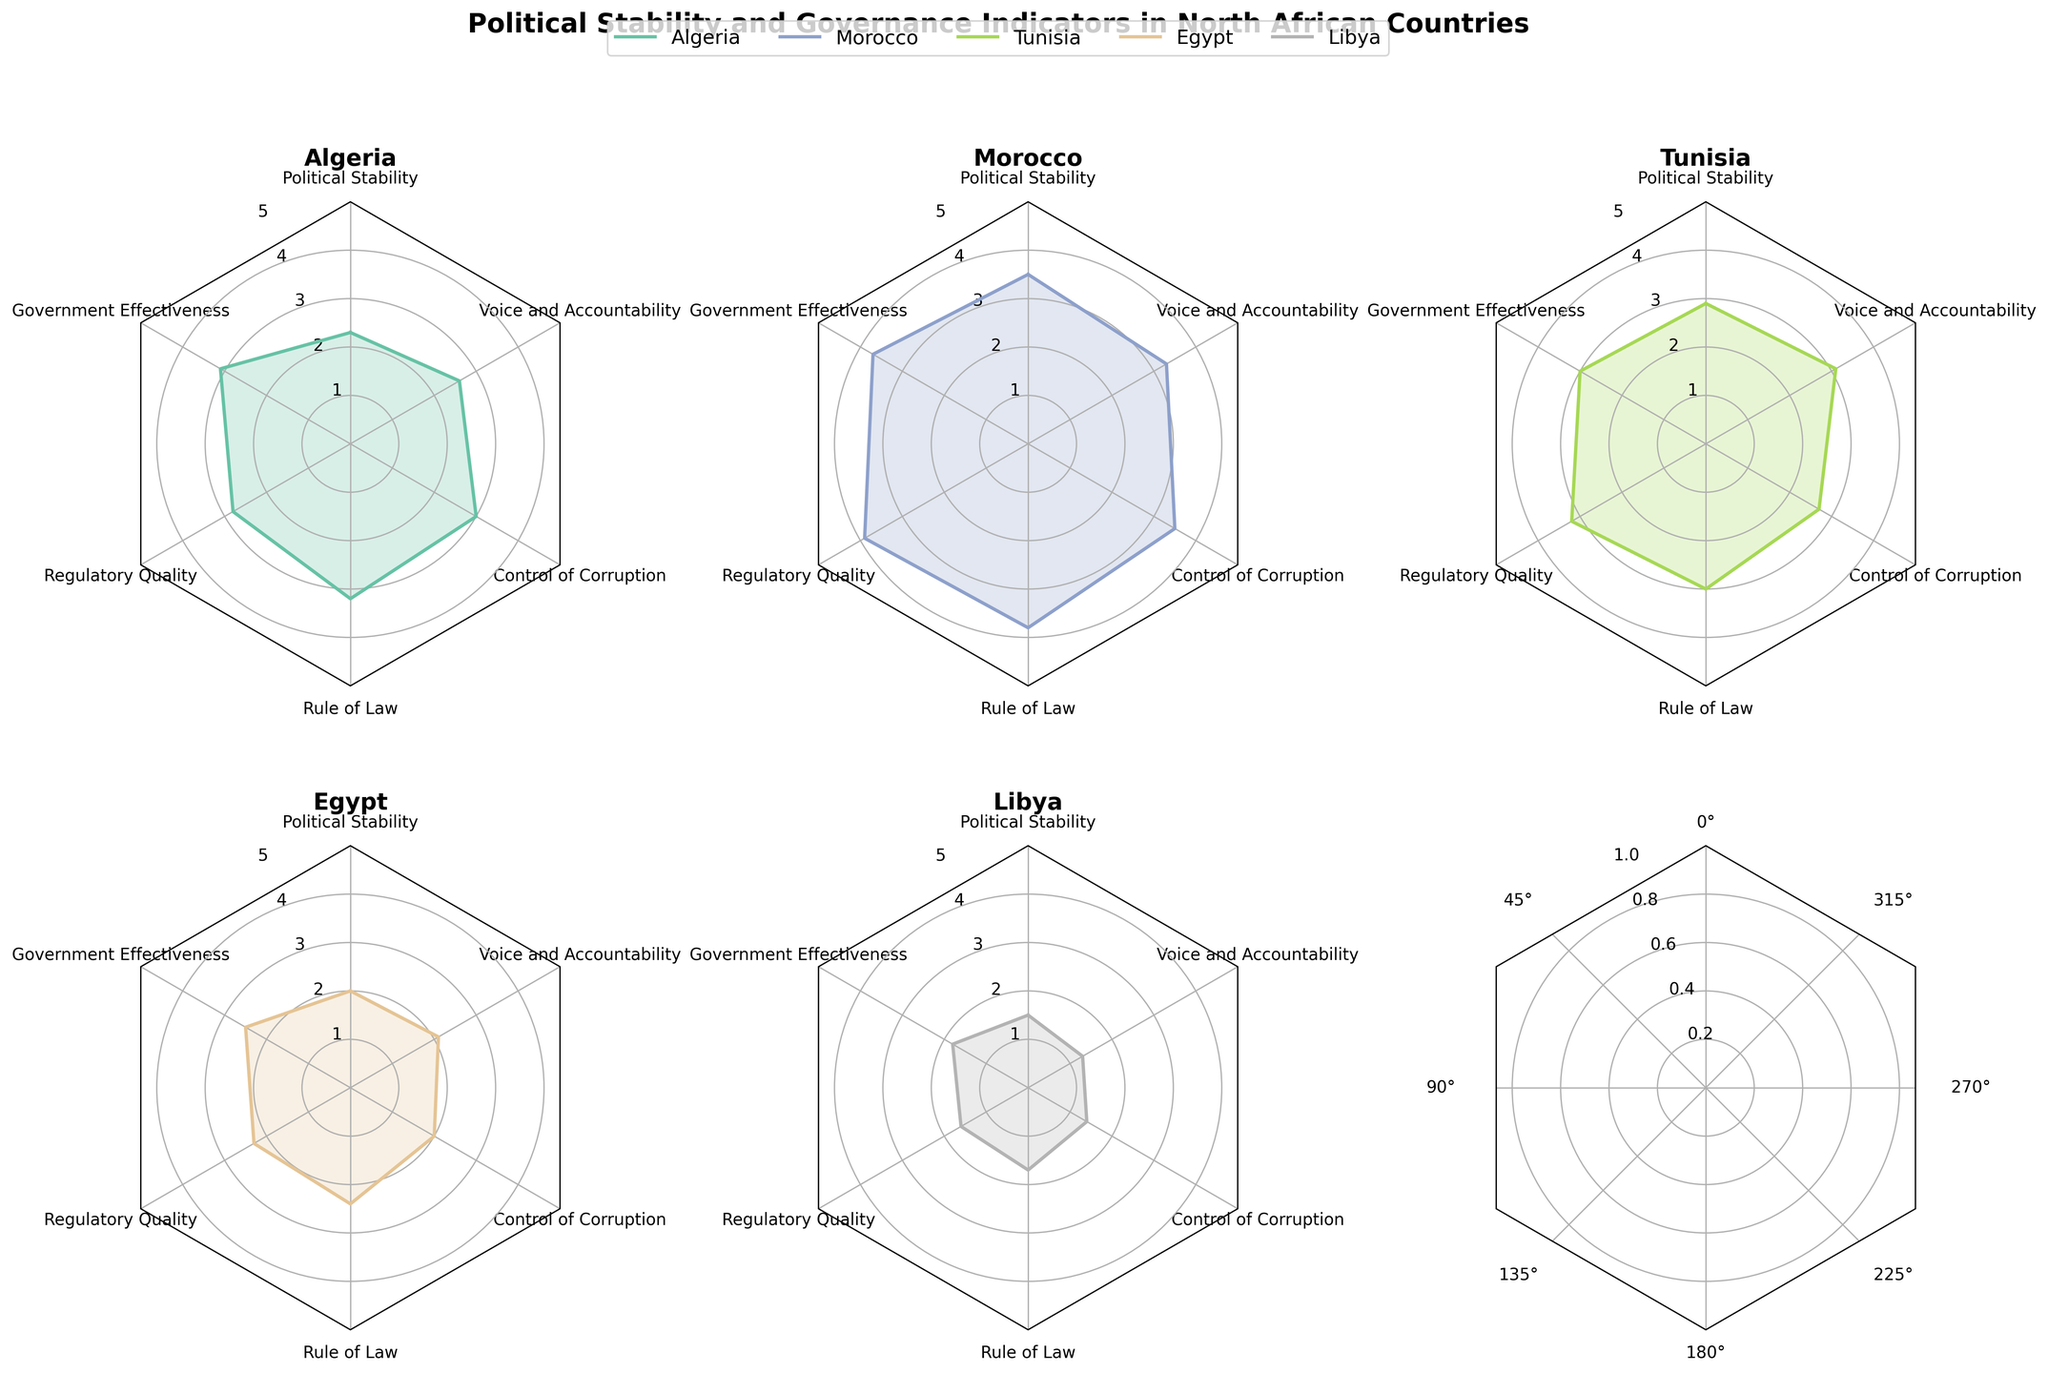What's the title of the figure? The title of the figure is usually located at the top center. In this case, it reads "Political Stability and Governance Indicators in North African Countries".
Answer: Political Stability and Governance Indicators in North African Countries How many countries are compared in the radar charts? By counting the number of radar charts in the figure, we see one for each country. There are five radar charts, indicating five countries.
Answer: Five Which country has the highest score in Regulatory Quality? To determine which country has the highest score, locate the Regulatory Quality indicator on each radar chart and compare the values. Morocco has the highest score in Regulatory Quality with a value of 3.9.
Answer: Morocco What is the difference in 'Political Stability' scores between Libya and Egypt? Identify the scores for 'Political Stability' for Libya (1.5) and Egypt (2.0). The difference is calculated by subtracting Libya's score from Egypt's: 2.0 - 1.5 = 0.5.
Answer: 0.5 Which country has the lowest score in 'Rule of Law'? Locate the 'Rule of Law' scores on each radar chart and find the smallest value. Libya has the lowest score in this category, with a value of 1.7.
Answer: Libya Between Tunisia and Algeria, which country scores higher in 'Voice and Accountability'? Check the 'Voice and Accountability' scores for Tunisia (3.1) and Algeria (2.6). Tunisia has a higher score.
Answer: Tunisia What scores the highest in 'Government Effectiveness' and in which country? Analyze each radar chart to find the maximum value of 'Government Effectiveness'. Morocco has the highest score with a value of 3.7 in this category.
Answer: Morocco, 3.7 What is the average score of Egypt across all indicators? To find the average, sum all the scores for Egypt (2.0 + 2.5 + 2.3 + 2.4 + 2.0 + 2.1 = 13.3) and divide by the number of indicators (6). The average score is 13.3 / 6 = 2.22.
Answer: 2.22 Which country has the most balanced scores across all indicators? A balanced score would imply little variation among the scores for that country. Examining the radar charts visually, Tunisia appears to have the most evenly distributed scores with values ranging from 2.7 to 3.2.
Answer: Tunisia 